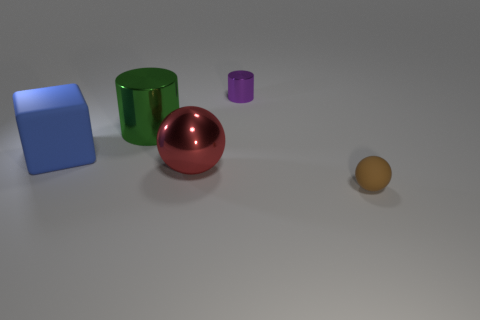Is the shape of the matte thing that is behind the tiny brown sphere the same as the large red metallic object to the left of the tiny metal cylinder? No, the shapes are not the same. The matte object behind the small brown sphere appears to be a cube, which has six equal square faces, while the large red metallic object to the left of the small metal cylinder has a cylindrical shape, characterized by its circular base and curved surface. 